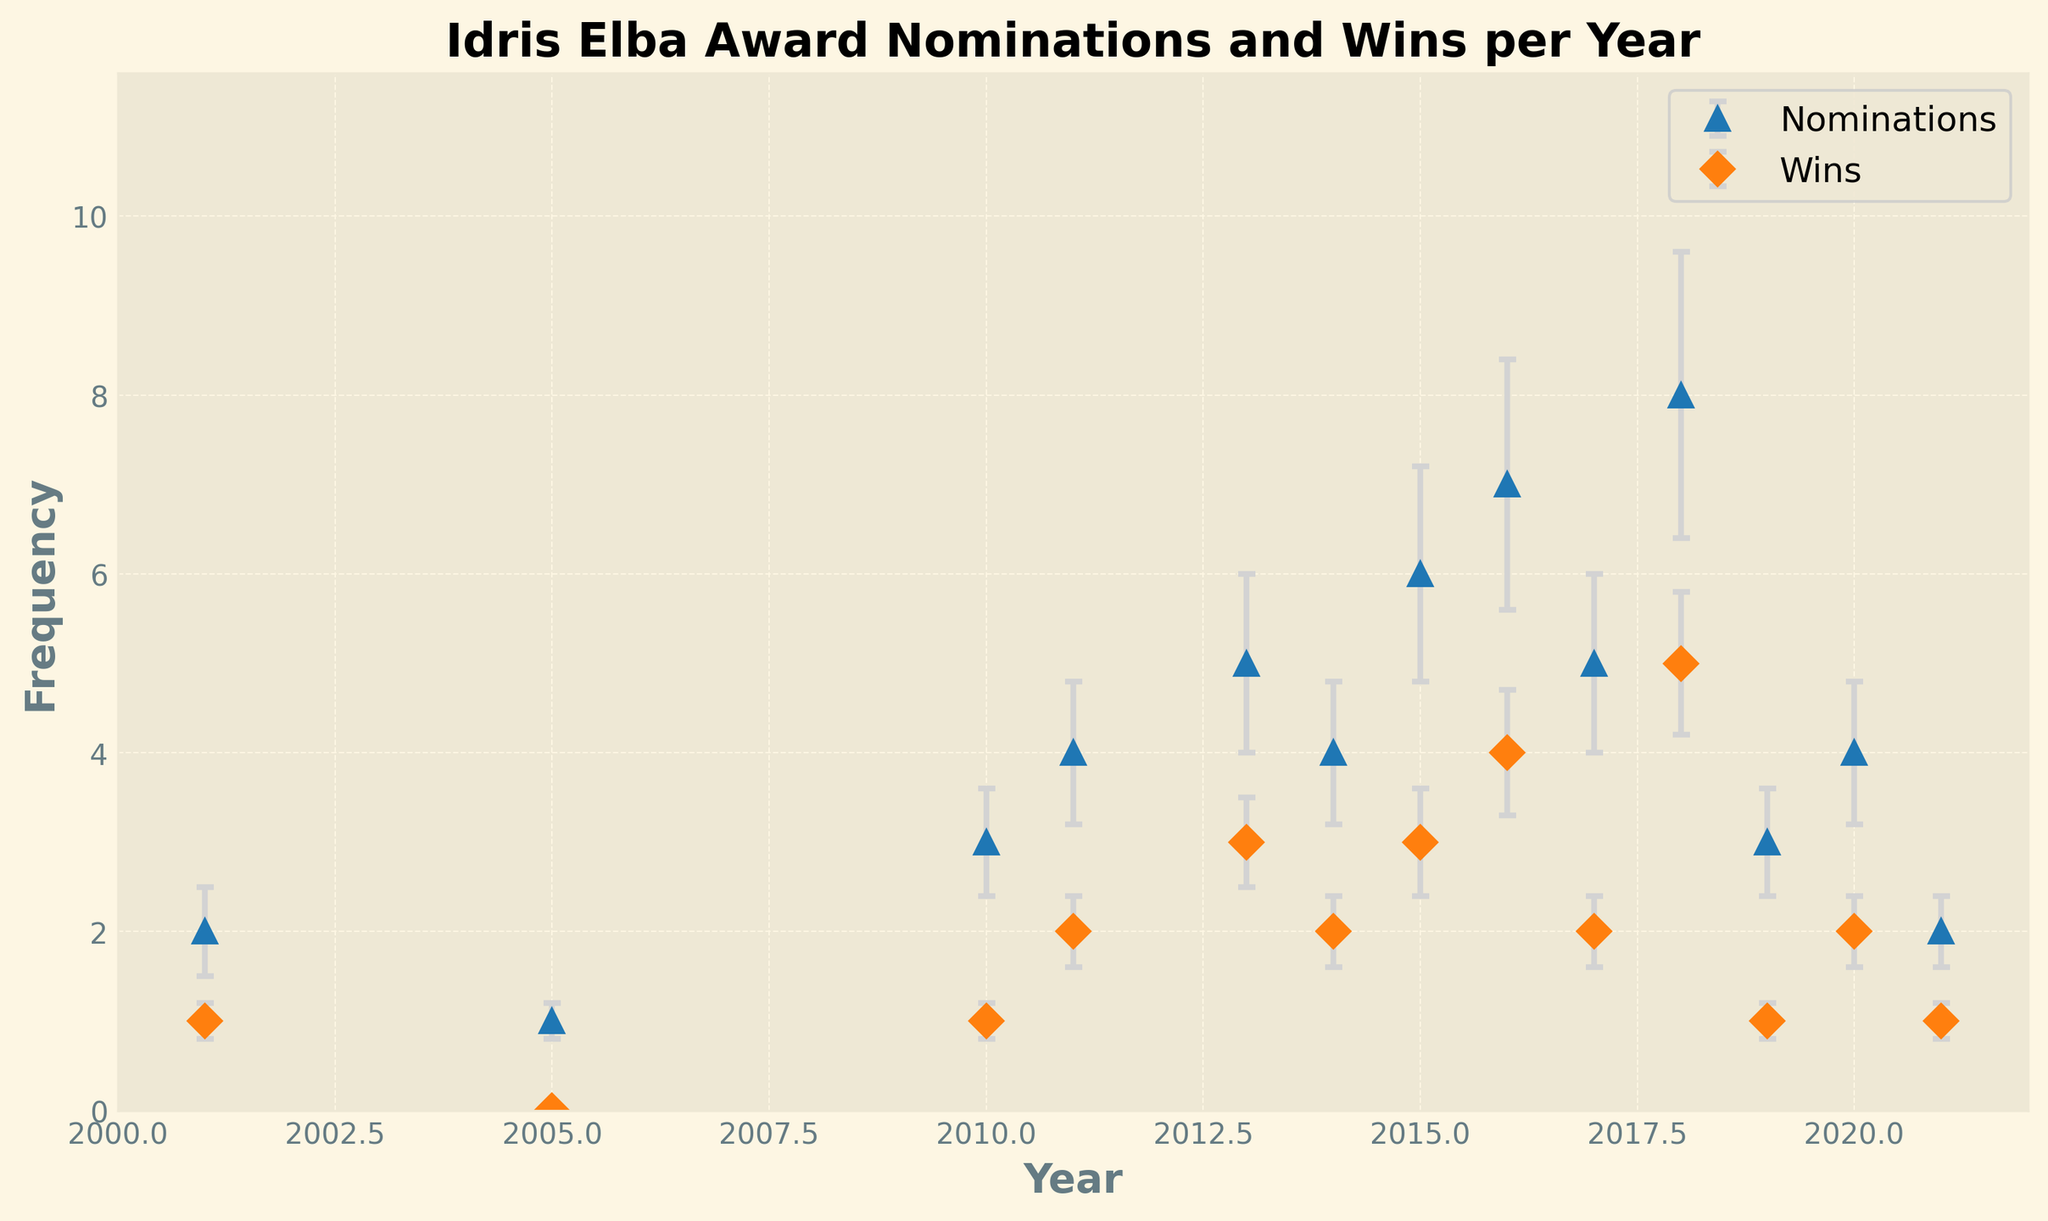How many years show Idris Elba having more wins than nominations? By observing the figure, you can see that there is no year where the number of wins exceeds the number of nominations. This makes logical sense because one must be nominated to win.
Answer: 0 In which year does Idris Elba have the highest number of nominations? By looking at the peaks of the blue line (nominations) in the figure, you can determine the highest nomination count. The peak occurs in 2018 with 8 nominations.
Answer: 2018 What is the average number of wins for the years with at least 4 nominations? Identify the years with at least 4 nominations (2011, 2013, 2014, 2015, 2016, 2017, 2018, 2020). Sum their win counts (2 + 3 + 2 + 3 + 4 + 2 + 5 + 2 = 23). Divide this sum by the number of such years (8). 23 / 8 = 2.875.
Answer: 2.875 Does Idris Elba's number of nominations trend upwards, downwards, or stay consistent over the years? By examining the overall trend in the nominations, there is a general increase in the number of nominations over the years, particularly after 2010.
Answer: Upwards In which year does Idris Elba have the smallest difference between nominations and wins? Calculate the difference for each year and find the smallest one. The differences are: 2001 (1), 2005 (1), 2010 (2), 2011 (2), 2013 (2), 2014 (2), 2015 (3), 2016 (3), 2017 (3), 2018 (3), 2019 (2), 2020 (2), 2021 (1). The smallest differences are in 2021, 2001, and 2005, all with a difference of 1.
Answer: 2001, 2005, 2021 Which year has the largest error margin for nominations? Compare the error margins shown by the error bars. The largest value of nominations_error is 1.6 which occurs in 2018.
Answer: 2018 What is the combined total of nominations and wins in 2015? Add the number of nominations and wins for the year 2015: 6 (nominations) + 3 (wins) = 9.
Answer: 9 What is the difference in the number of wins between 2016 and 2017? Find the number of wins for 2016 (4) and the number of wins for 2017 (2), then calculate the difference: 4 - 2 = 2.
Answer: 2 